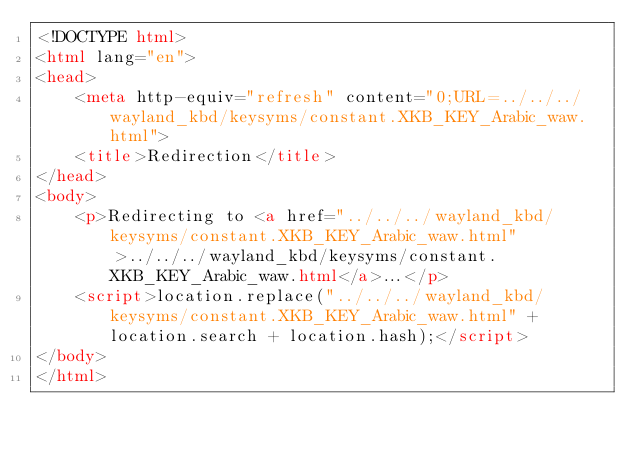<code> <loc_0><loc_0><loc_500><loc_500><_HTML_><!DOCTYPE html>
<html lang="en">
<head>
    <meta http-equiv="refresh" content="0;URL=../../../wayland_kbd/keysyms/constant.XKB_KEY_Arabic_waw.html">
    <title>Redirection</title>
</head>
<body>
    <p>Redirecting to <a href="../../../wayland_kbd/keysyms/constant.XKB_KEY_Arabic_waw.html">../../../wayland_kbd/keysyms/constant.XKB_KEY_Arabic_waw.html</a>...</p>
    <script>location.replace("../../../wayland_kbd/keysyms/constant.XKB_KEY_Arabic_waw.html" + location.search + location.hash);</script>
</body>
</html></code> 